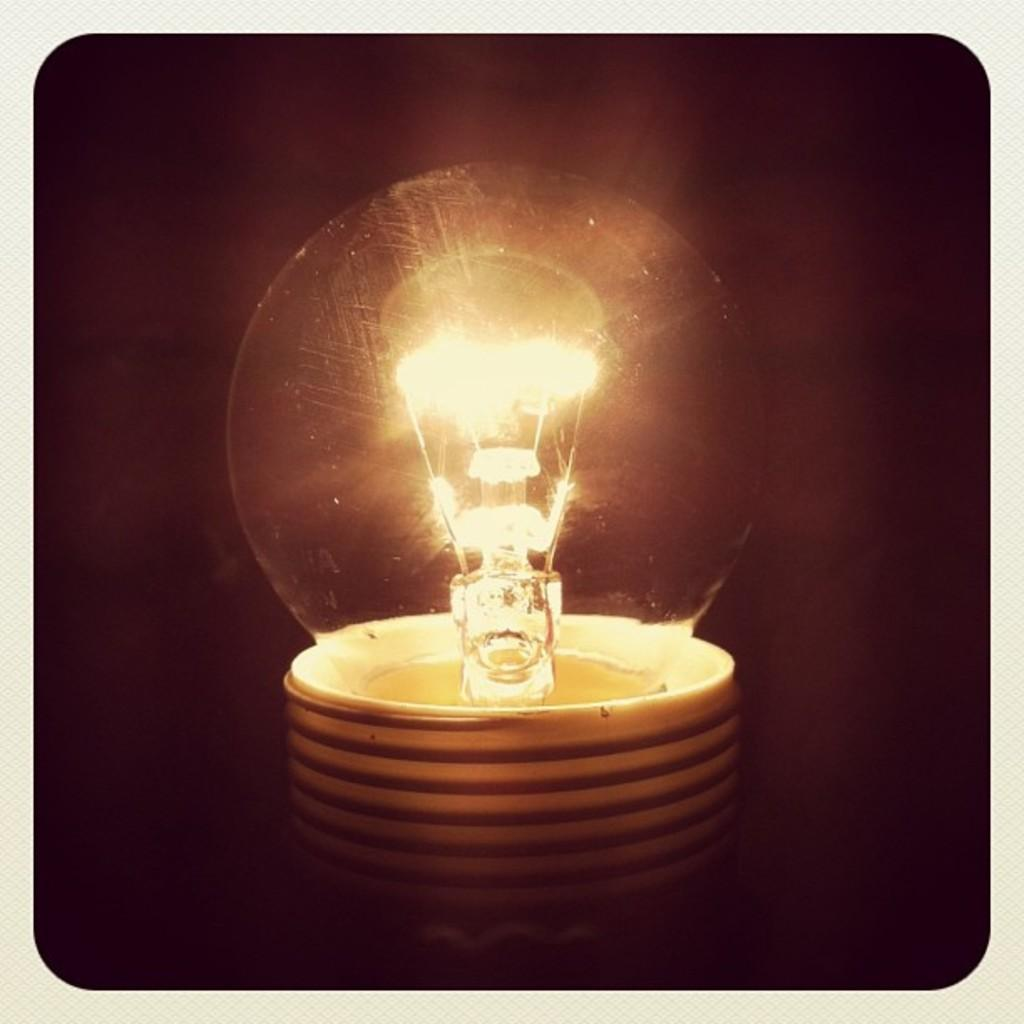What object is the main focus of the image? There is a bulb in the image. What can be inferred about the environment in which the image was taken? The background of the image is black, possibly due to the image being taken in a dark environment. What type of oil is being used by the father in the image? There is no father or oil present in the image; it only features a bulb. 